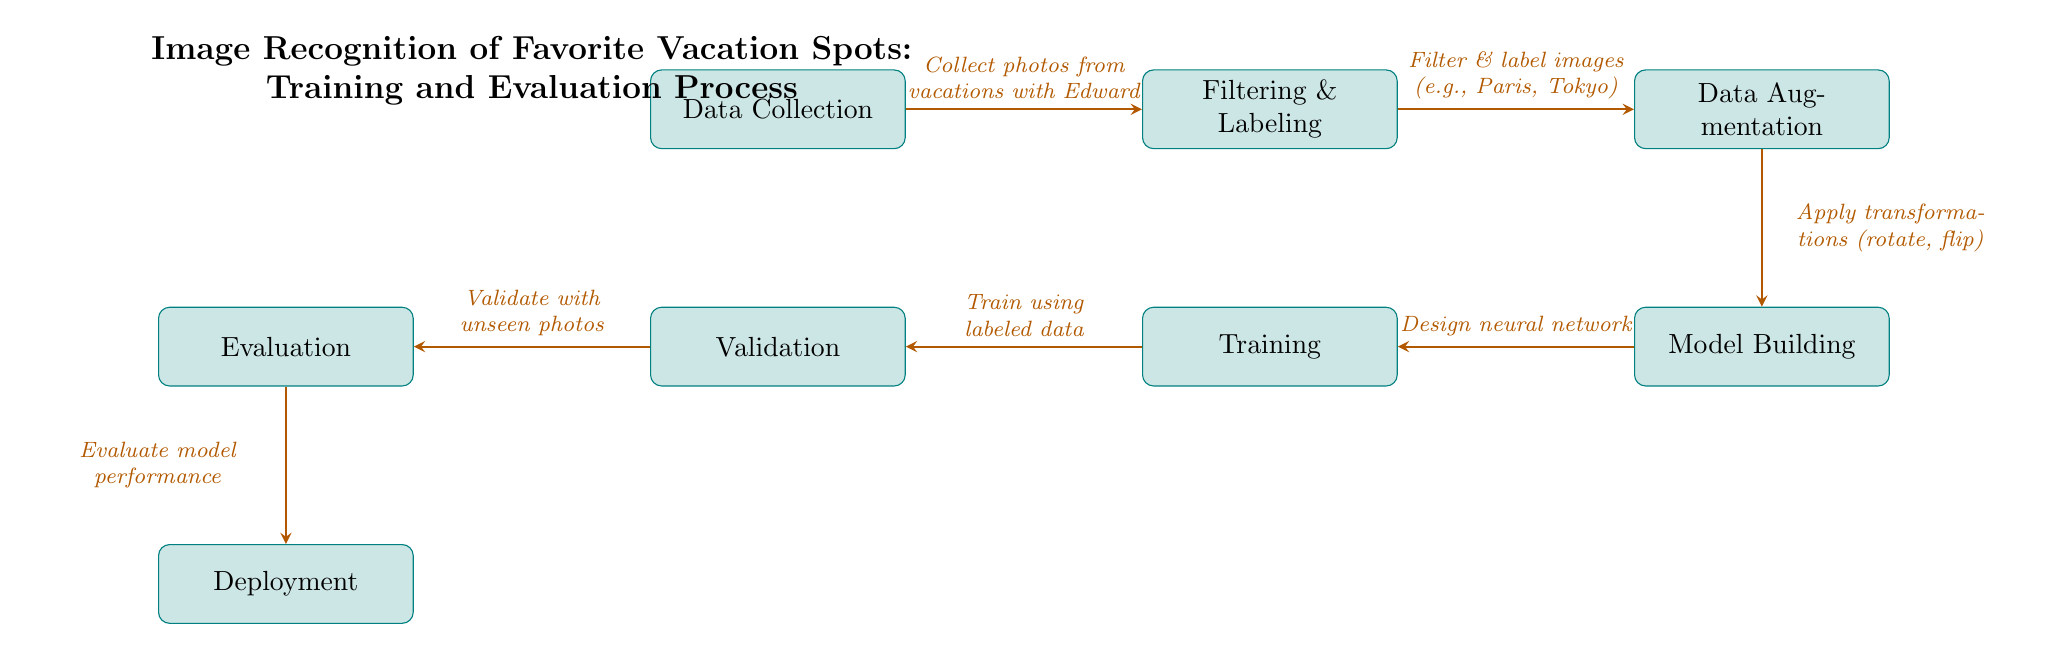What is the first step in the process? The diagram indicates that the first step is "Data Collection," which is shown at the top left of the diagram.
Answer: Data Collection How many main processes are displayed in the diagram? The diagram lists a total of six main processes including Data Collection, Filtering & Labeling, Data Augmentation, Model Building, Training, Validation, Evaluation, and Deployment. Counting them gives us a total of seven.
Answer: Seven Which process comes after 'Filtering & Labeling'? The arrow indicates that 'Data Augmentation' follows directly after 'Filtering & Labeling' in the flow of the diagram.
Answer: Data Augmentation What is the purpose of 'Validation' in the diagram? 'Validation' is positioned to ensure that unseen photos are used to validate the model after the training process. This determines how well the model can generalize to new data.
Answer: Validate with unseen photos What step follows 'Evaluation'? According to the flow of the diagram, 'Deployment' follows after 'Evaluation,' marking the end of the training and evaluation process before the model is put into use.
Answer: Deployment Which process involves applying transformations like rotating and flipping? 'Data Augmentation' is the process where techniques like rotating and flipping images are applied to enhance the dataset.
Answer: Data Augmentation What stage comes before 'Model Building'? 'Data Augmentation' is the stage that comes immediately before 'Model Building' in the training and evaluation process, focusing on enhancing the dataset.
Answer: Data Augmentation Explain the relationship between 'Training' and 'Validation.' 'Training' occurs after the model has been built using the labeled data, while 'Validation' utilizes unseen photos to check the accuracy of the model trained in the 'Training' phase, thereby ensuring it performs well on new data.
Answer: Training uses labeled data; Validation checks accuracy 